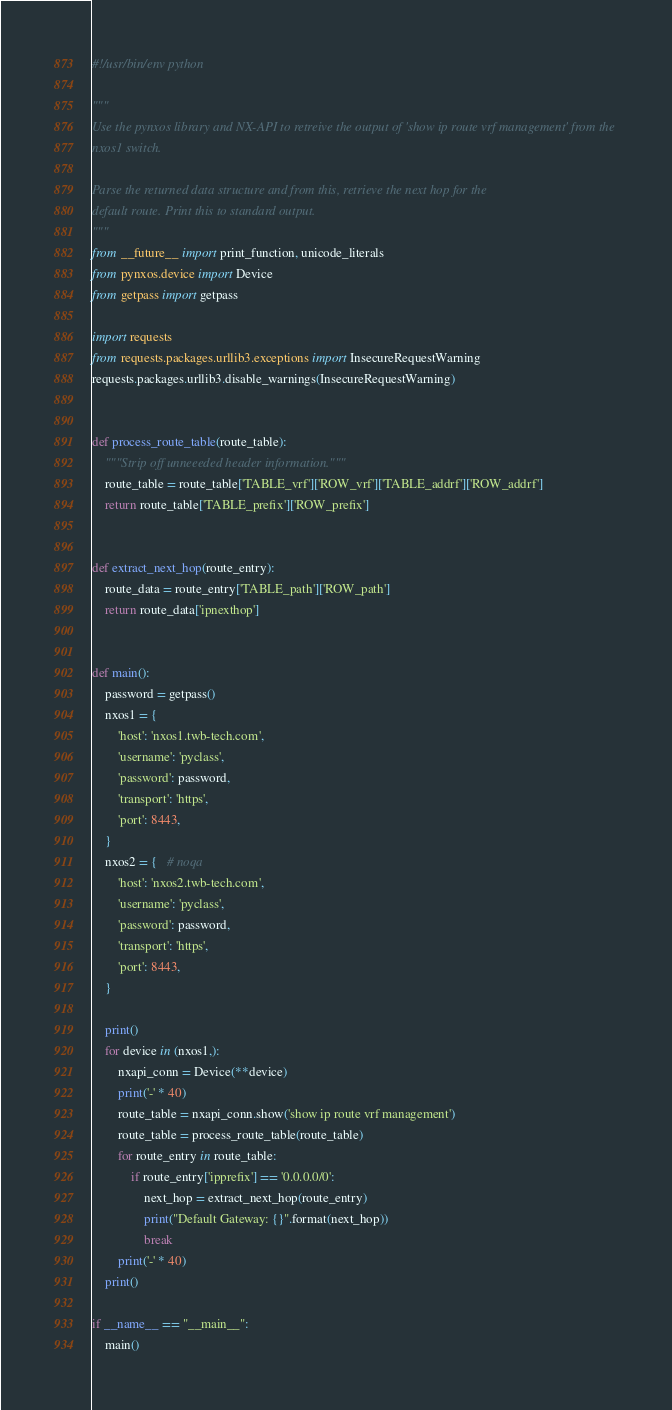<code> <loc_0><loc_0><loc_500><loc_500><_Python_>#!/usr/bin/env python

"""
Use the pynxos library and NX-API to retreive the output of 'show ip route vrf management' from the
nxos1 switch.

Parse the returned data structure and from this, retrieve the next hop for the
default route. Print this to standard output.
"""
from __future__ import print_function, unicode_literals
from pynxos.device import Device
from getpass import getpass

import requests
from requests.packages.urllib3.exceptions import InsecureRequestWarning
requests.packages.urllib3.disable_warnings(InsecureRequestWarning)


def process_route_table(route_table):
    """Strip off unneeeded header information."""
    route_table = route_table['TABLE_vrf']['ROW_vrf']['TABLE_addrf']['ROW_addrf']
    return route_table['TABLE_prefix']['ROW_prefix']


def extract_next_hop(route_entry):
    route_data = route_entry['TABLE_path']['ROW_path']
    return route_data['ipnexthop']


def main():
    password = getpass()
    nxos1 = {
        'host': 'nxos1.twb-tech.com',
        'username': 'pyclass',
        'password': password,
        'transport': 'https',
        'port': 8443,
    }
    nxos2 = {   # noqa
        'host': 'nxos2.twb-tech.com',
        'username': 'pyclass',
        'password': password,
        'transport': 'https',
        'port': 8443,
    }

    print()
    for device in (nxos1,):
        nxapi_conn = Device(**device)
        print('-' * 40)
        route_table = nxapi_conn.show('show ip route vrf management')
        route_table = process_route_table(route_table)
        for route_entry in route_table:
            if route_entry['ipprefix'] == '0.0.0.0/0':
                next_hop = extract_next_hop(route_entry)
                print("Default Gateway: {}".format(next_hop))
                break
        print('-' * 40)
    print()

if __name__ == "__main__":
    main()

</code> 